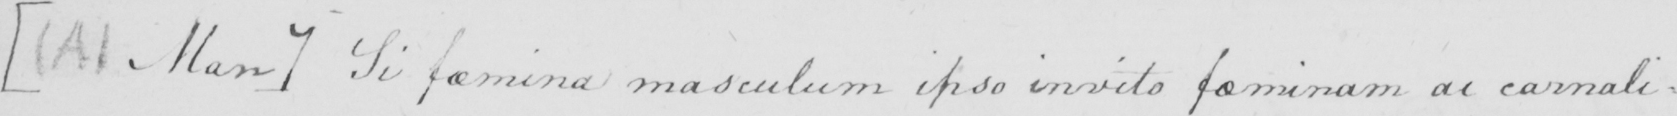Can you tell me what this handwritten text says? [  ( A )  Man ]  Si famina masculaum ipso invito faminam ai carnali : 